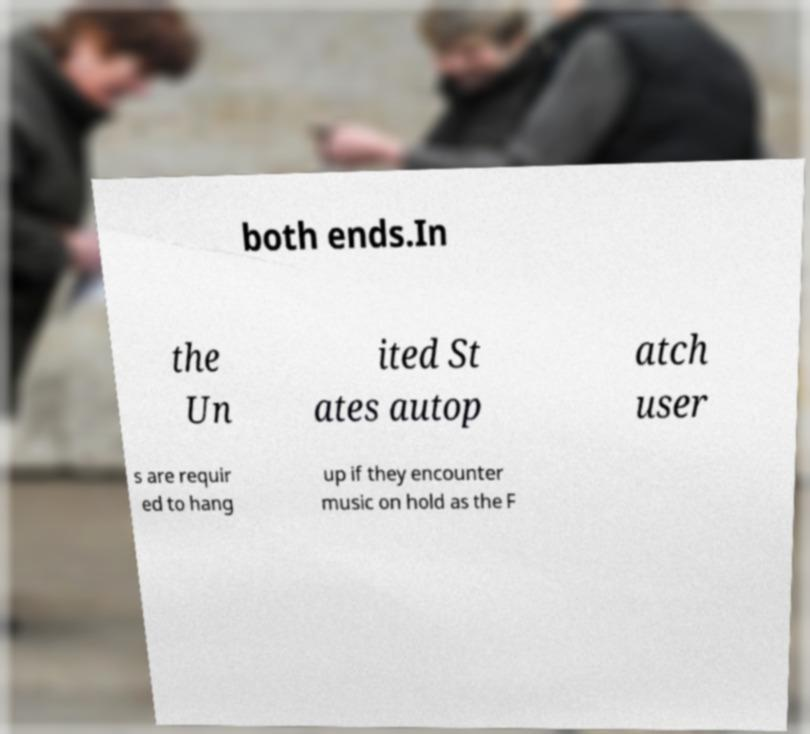I need the written content from this picture converted into text. Can you do that? both ends.In the Un ited St ates autop atch user s are requir ed to hang up if they encounter music on hold as the F 